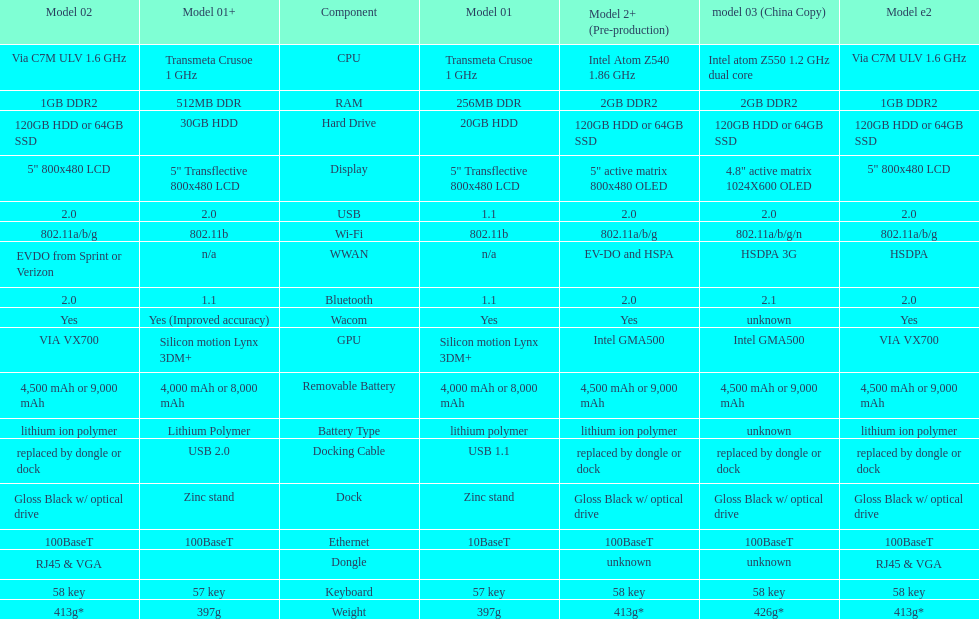The model 2 and the model 2e have what type of cpu? Via C7M ULV 1.6 GHz. Would you be able to parse every entry in this table? {'header': ['Model 02', 'Model 01+', 'Component', 'Model 01', 'Model 2+ (Pre-production)', 'model 03 (China Copy)', 'Model e2'], 'rows': [['Via C7M ULV 1.6\xa0GHz', 'Transmeta Crusoe 1\xa0GHz', 'CPU', 'Transmeta Crusoe 1\xa0GHz', 'Intel Atom Z540 1.86\xa0GHz', 'Intel atom Z550 1.2\xa0GHz dual core', 'Via C7M ULV 1.6\xa0GHz'], ['1GB DDR2', '512MB DDR', 'RAM', '256MB DDR', '2GB DDR2', '2GB DDR2', '1GB DDR2'], ['120GB HDD or 64GB SSD', '30GB HDD', 'Hard Drive', '20GB HDD', '120GB HDD or 64GB SSD', '120GB HDD or 64GB SSD', '120GB HDD or 64GB SSD'], ['5" 800x480 LCD', '5" Transflective 800x480 LCD', 'Display', '5" Transflective 800x480 LCD', '5" active matrix 800x480 OLED', '4.8" active matrix 1024X600 OLED', '5" 800x480 LCD'], ['2.0', '2.0', 'USB', '1.1', '2.0', '2.0', '2.0'], ['802.11a/b/g', '802.11b', 'Wi-Fi', '802.11b', '802.11a/b/g', '802.11a/b/g/n', '802.11a/b/g'], ['EVDO from Sprint or Verizon', 'n/a', 'WWAN', 'n/a', 'EV-DO and HSPA', 'HSDPA 3G', 'HSDPA'], ['2.0', '1.1', 'Bluetooth', '1.1', '2.0', '2.1', '2.0'], ['Yes', 'Yes (Improved accuracy)', 'Wacom', 'Yes', 'Yes', 'unknown', 'Yes'], ['VIA VX700', 'Silicon motion Lynx 3DM+', 'GPU', 'Silicon motion Lynx 3DM+', 'Intel GMA500', 'Intel GMA500', 'VIA VX700'], ['4,500 mAh or 9,000 mAh', '4,000 mAh or 8,000 mAh', 'Removable Battery', '4,000 mAh or 8,000 mAh', '4,500 mAh or 9,000 mAh', '4,500 mAh or 9,000 mAh', '4,500 mAh or 9,000 mAh'], ['lithium ion polymer', 'Lithium Polymer', 'Battery Type', 'lithium polymer', 'lithium ion polymer', 'unknown', 'lithium ion polymer'], ['replaced by dongle or dock', 'USB 2.0', 'Docking Cable', 'USB 1.1', 'replaced by dongle or dock', 'replaced by dongle or dock', 'replaced by dongle or dock'], ['Gloss Black w/ optical drive', 'Zinc stand', 'Dock', 'Zinc stand', 'Gloss Black w/ optical drive', 'Gloss Black w/ optical drive', 'Gloss Black w/ optical drive'], ['100BaseT', '100BaseT', 'Ethernet', '10BaseT', '100BaseT', '100BaseT', '100BaseT'], ['RJ45 & VGA', '', 'Dongle', '', 'unknown', 'unknown', 'RJ45 & VGA'], ['58 key', '57 key', 'Keyboard', '57 key', '58 key', '58 key', '58 key'], ['413g*', '397g', 'Weight', '397g', '413g*', '426g*', '413g*']]} 